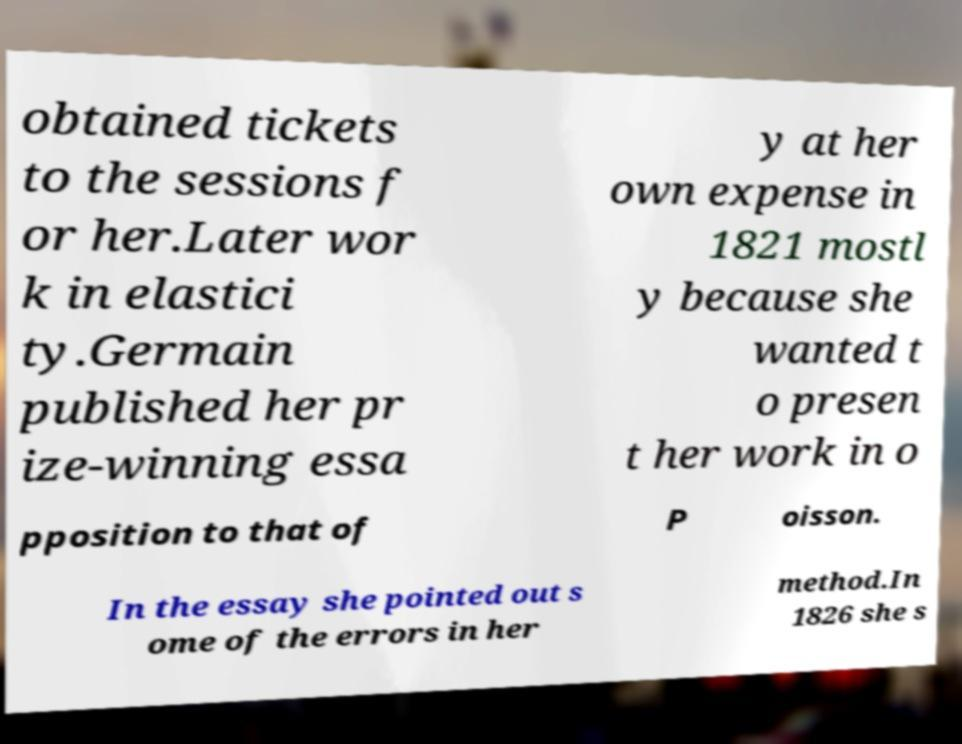Please read and relay the text visible in this image. What does it say? obtained tickets to the sessions f or her.Later wor k in elastici ty.Germain published her pr ize-winning essa y at her own expense in 1821 mostl y because she wanted t o presen t her work in o pposition to that of P oisson. In the essay she pointed out s ome of the errors in her method.In 1826 she s 